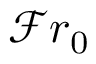Convert formula to latex. <formula><loc_0><loc_0><loc_500><loc_500>\mathcal { F } r _ { 0 }</formula> 